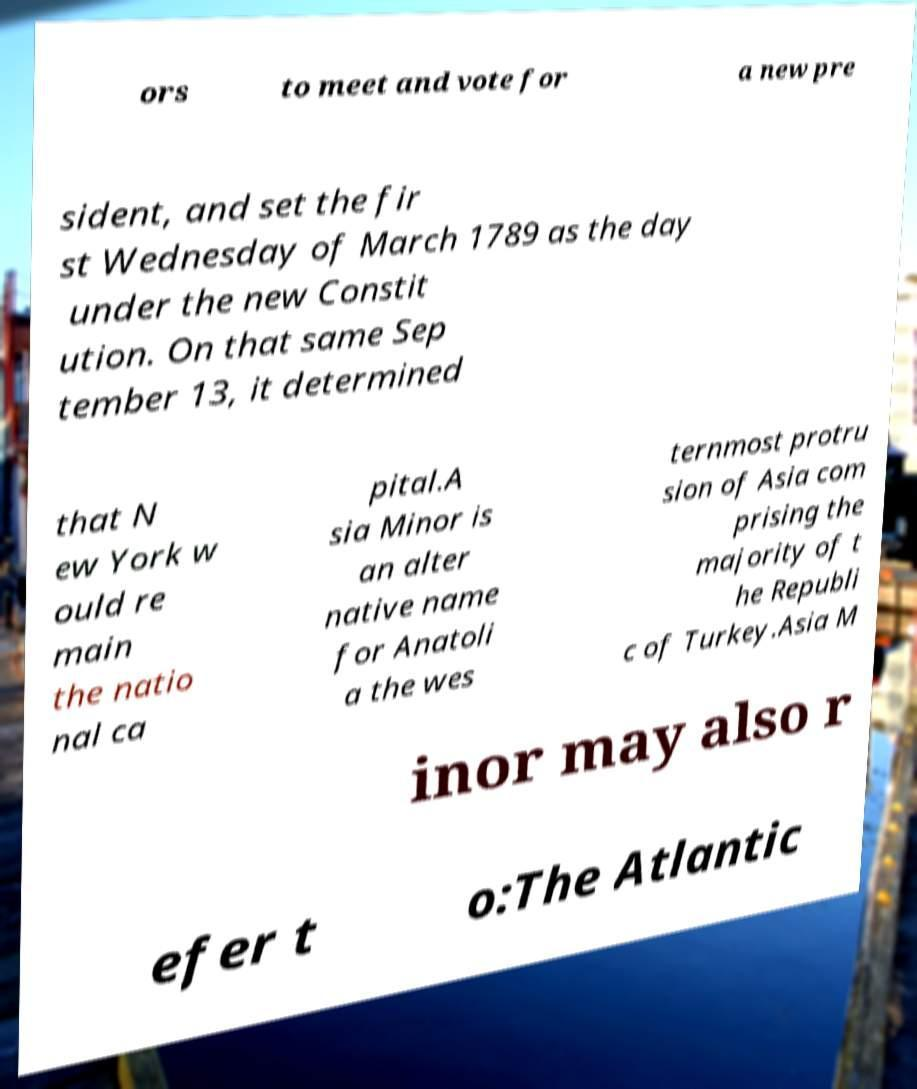Could you assist in decoding the text presented in this image and type it out clearly? ors to meet and vote for a new pre sident, and set the fir st Wednesday of March 1789 as the day under the new Constit ution. On that same Sep tember 13, it determined that N ew York w ould re main the natio nal ca pital.A sia Minor is an alter native name for Anatoli a the wes ternmost protru sion of Asia com prising the majority of t he Republi c of Turkey.Asia M inor may also r efer t o:The Atlantic 